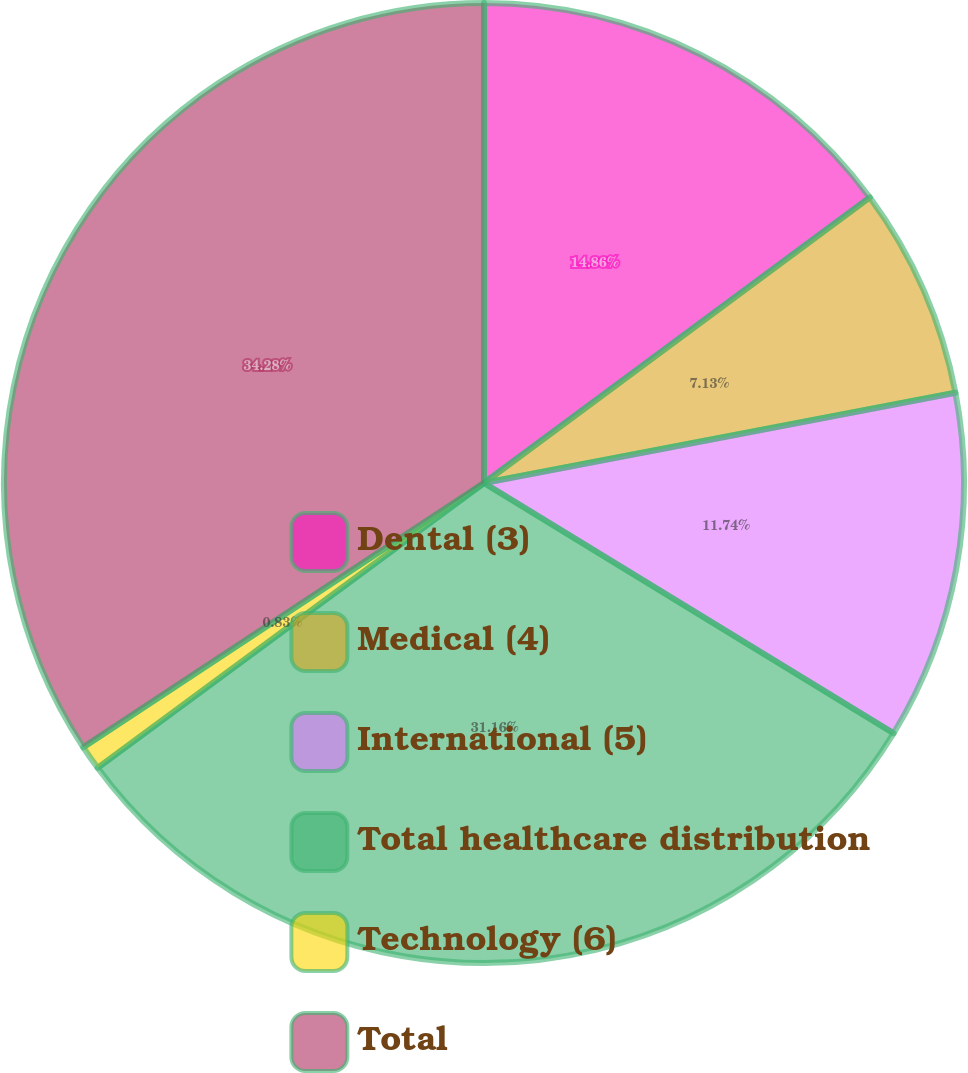Convert chart to OTSL. <chart><loc_0><loc_0><loc_500><loc_500><pie_chart><fcel>Dental (3)<fcel>Medical (4)<fcel>International (5)<fcel>Total healthcare distribution<fcel>Technology (6)<fcel>Total<nl><fcel>14.86%<fcel>7.13%<fcel>11.74%<fcel>31.16%<fcel>0.83%<fcel>34.28%<nl></chart> 